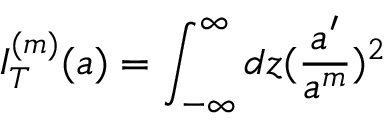<formula> <loc_0><loc_0><loc_500><loc_500>I _ { T } ^ { ( m ) } ( a ) = \int _ { - \infty } ^ { \infty } d z ( \frac { a ^ { \prime } } { a ^ { m } } ) ^ { 2 }</formula> 